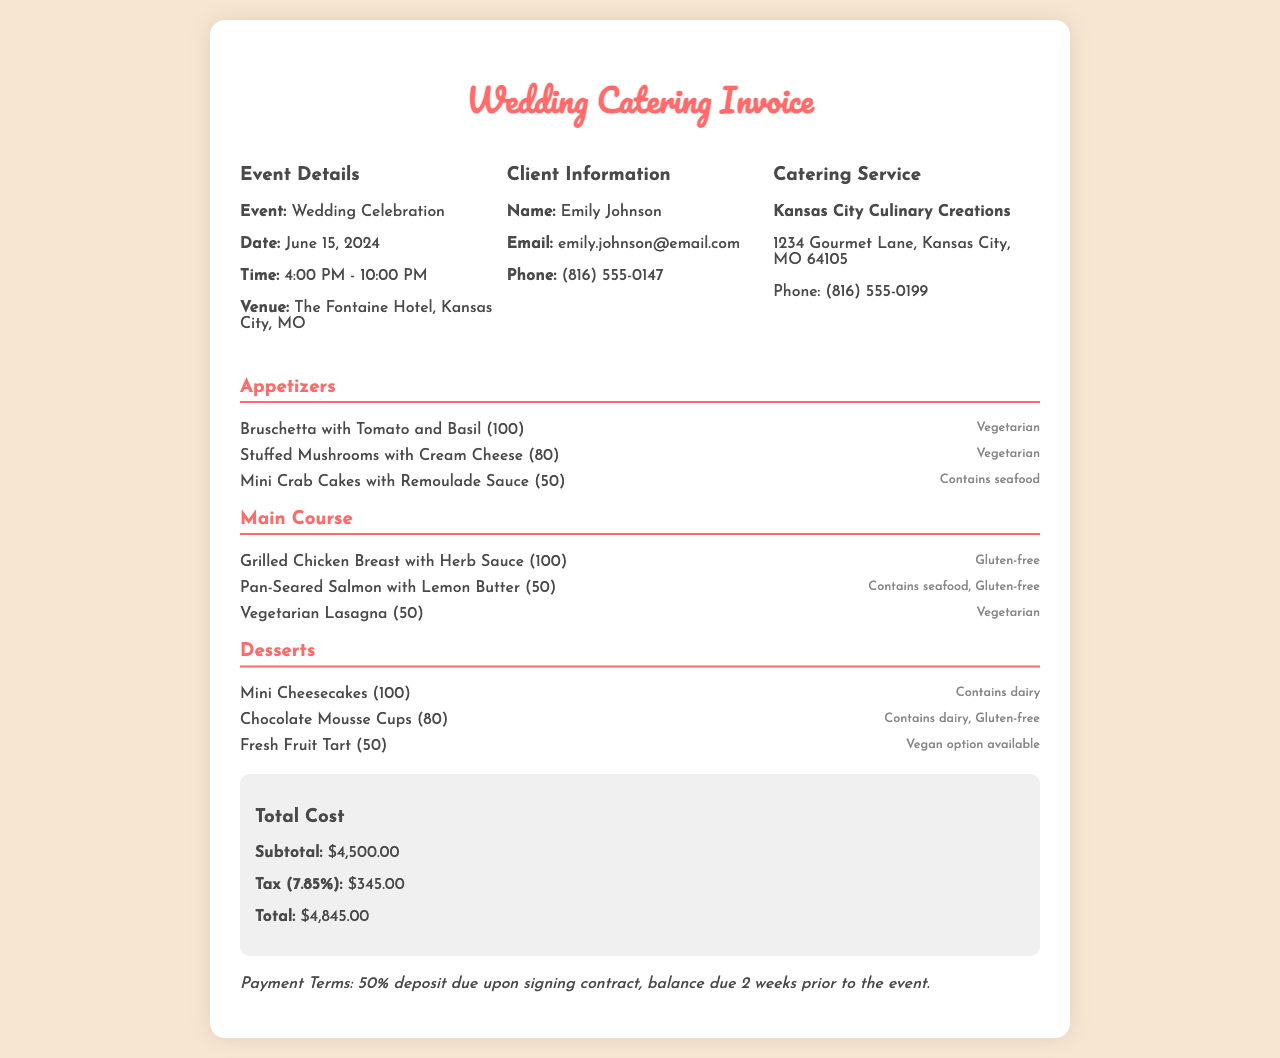what is the event date? The event date is specified in the document as June 15, 2024.
Answer: June 15, 2024 how many appetizers are there? The document lists three appetizers under the menu section.
Answer: 3 who is the client? The name of the client is provided in the client information section.
Answer: Emily Johnson what is the total cost? The total cost is explicitly stated in the total cost section of the document.
Answer: $4,845.00 which item is gluten-free in the main course? The document mentions one gluten-free item in the main course.
Answer: Grilled Chicken Breast with Herb Sauce what is the venue for the event? The venue information is included in the event details section.
Answer: The Fontaine Hotel, Kansas City, MO what payment terms are mentioned? The payment terms are listed in the payment terms section of the invoice.
Answer: 50% deposit due upon signing contract how many vegetarian appetizers are there? The document states that two of the appetizers are vegetarian.
Answer: 2 what is the dietary note for the Mini Cheesecakes? The dietary note for the Mini Cheesecakes is provided next to the item in the desserts section.
Answer: Contains dairy 